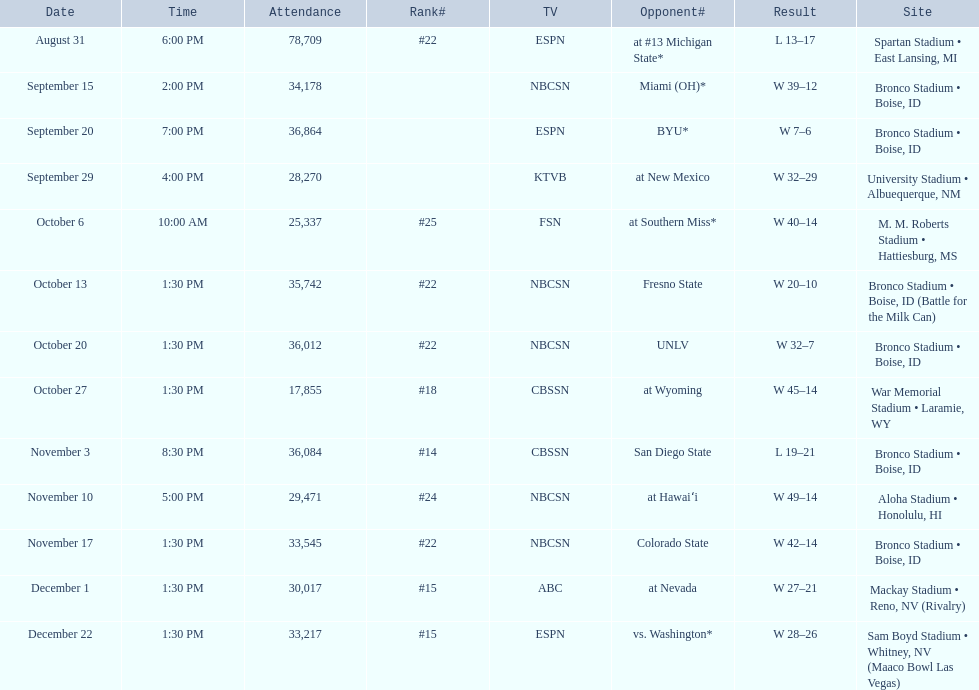What are all of the rankings? #22, , , , #25, #22, #22, #18, #14, #24, #22, #15, #15. Which of them was the best position? #14. 